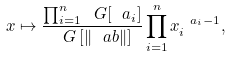Convert formula to latex. <formula><loc_0><loc_0><loc_500><loc_500>x \mapsto \frac { \prod _ { i = 1 } ^ { n } \ G [ \ a _ { i } ] } { \ G \left [ \| \ a b \| \right ] } \prod _ { i = 1 } ^ { n } x _ { i } ^ { \ a _ { i } - 1 } ,</formula> 